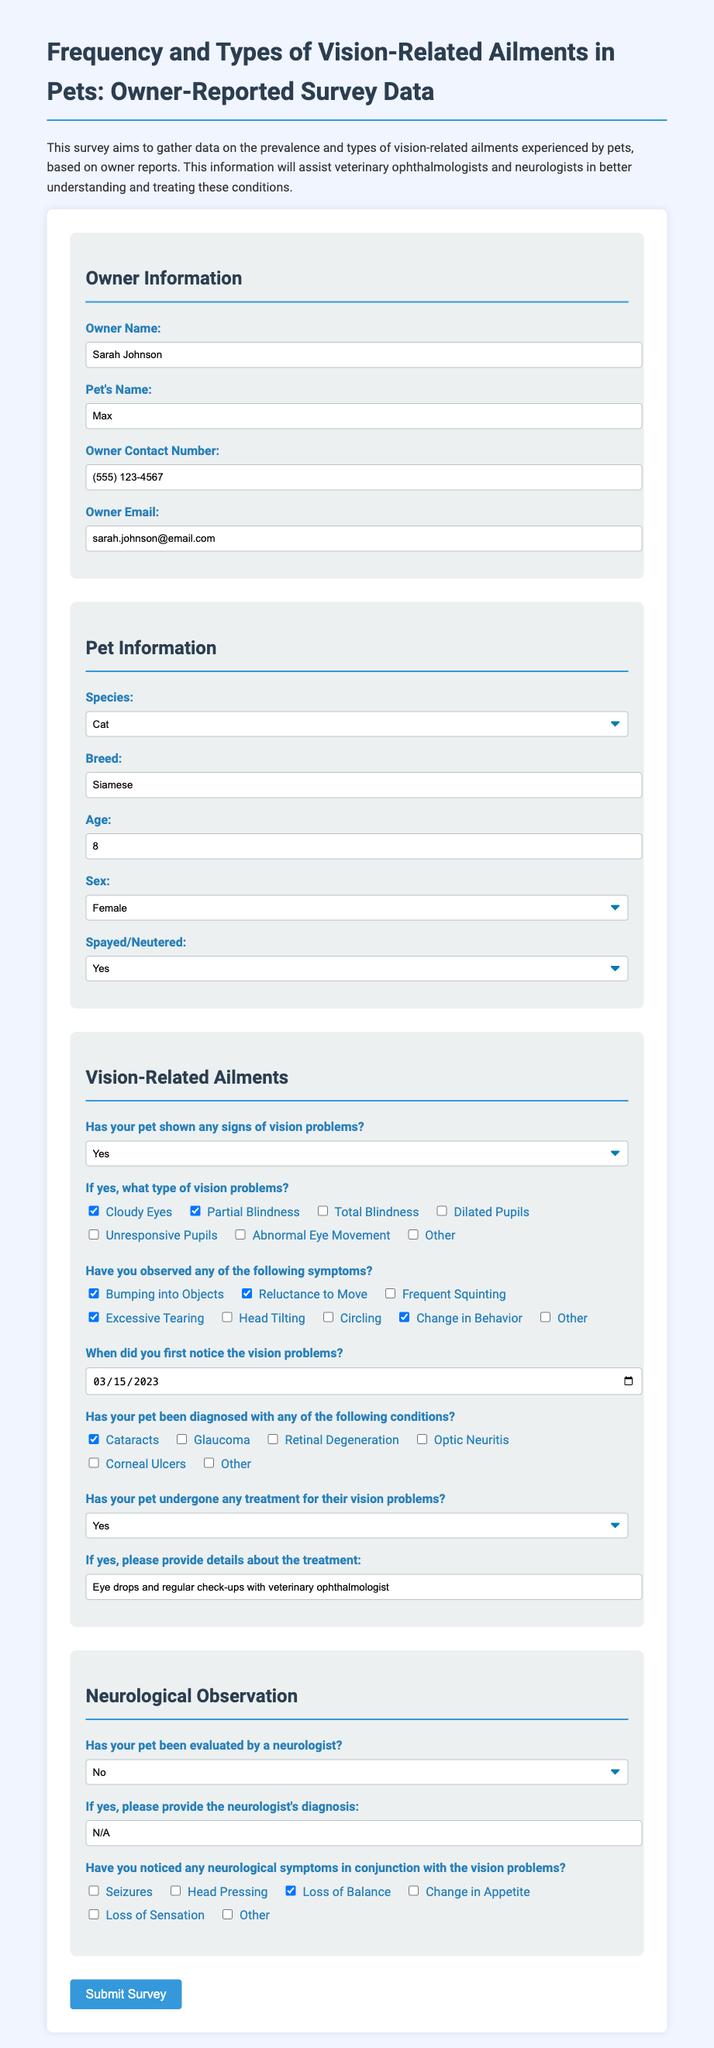What is the owner's name? The owner's name is indicated in the Owner Information section of the form.
Answer: Sarah Johnson What type of pet does the owner have? The species of the pet is specified in the Pet Information section.
Answer: Cat What is the age of the pet? The age of the pet is recorded in the Pet Information section as a number.
Answer: 8 What type of vision problems has the pet shown? The specific vision problems are listed in the Vision-Related Ailments section where the owner can select from multiple options.
Answer: Cloudy Eyes, Partial Blindness When did the owner first notice the vision problems? The date when the vision problems were first noticed is recorded in the Vision-Related Ailments section.
Answer: 2023-03-15 Has the pet undergone treatment for vision problems? The document contains a question about treatment in the Vision-Related Ailments section that can be answered with Yes or No.
Answer: Yes Has the pet been evaluated by a neurologist? This information is recorded in the Neurological Observation section where a Yes or No response is required.
Answer: No What neurological symptom has the owner noticed? The document includes a checklist for neurological symptoms in conjunction with the vision problems.
Answer: Loss of Balance What details does the owner provide about the treatment? A specific input field allows the owner to detail treatment undertaken for vision problems.
Answer: Eye drops and regular check-ups with veterinary ophthalmologist 